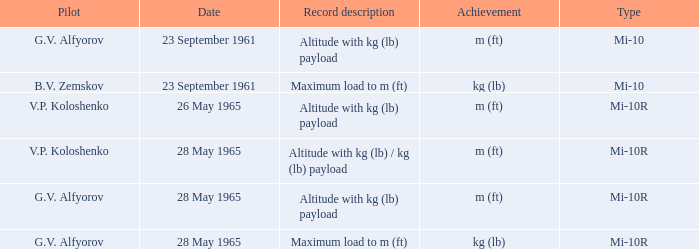Achievement of m (ft), and a Type of mi-10r, and a Pilot of v.p. koloshenko, and a Date of 28 may 1965 had what record description? Altitude with kg (lb) / kg (lb) payload. 